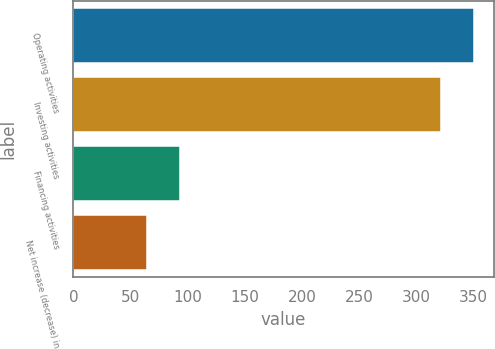<chart> <loc_0><loc_0><loc_500><loc_500><bar_chart><fcel>Operating activities<fcel>Investing activities<fcel>Financing activities<fcel>Net increase (decrease) in<nl><fcel>349.9<fcel>321.3<fcel>92.8<fcel>64.2<nl></chart> 